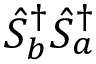Convert formula to latex. <formula><loc_0><loc_0><loc_500><loc_500>\hat { S } _ { b } ^ { \dagger } \hat { S } _ { a } ^ { \dagger }</formula> 